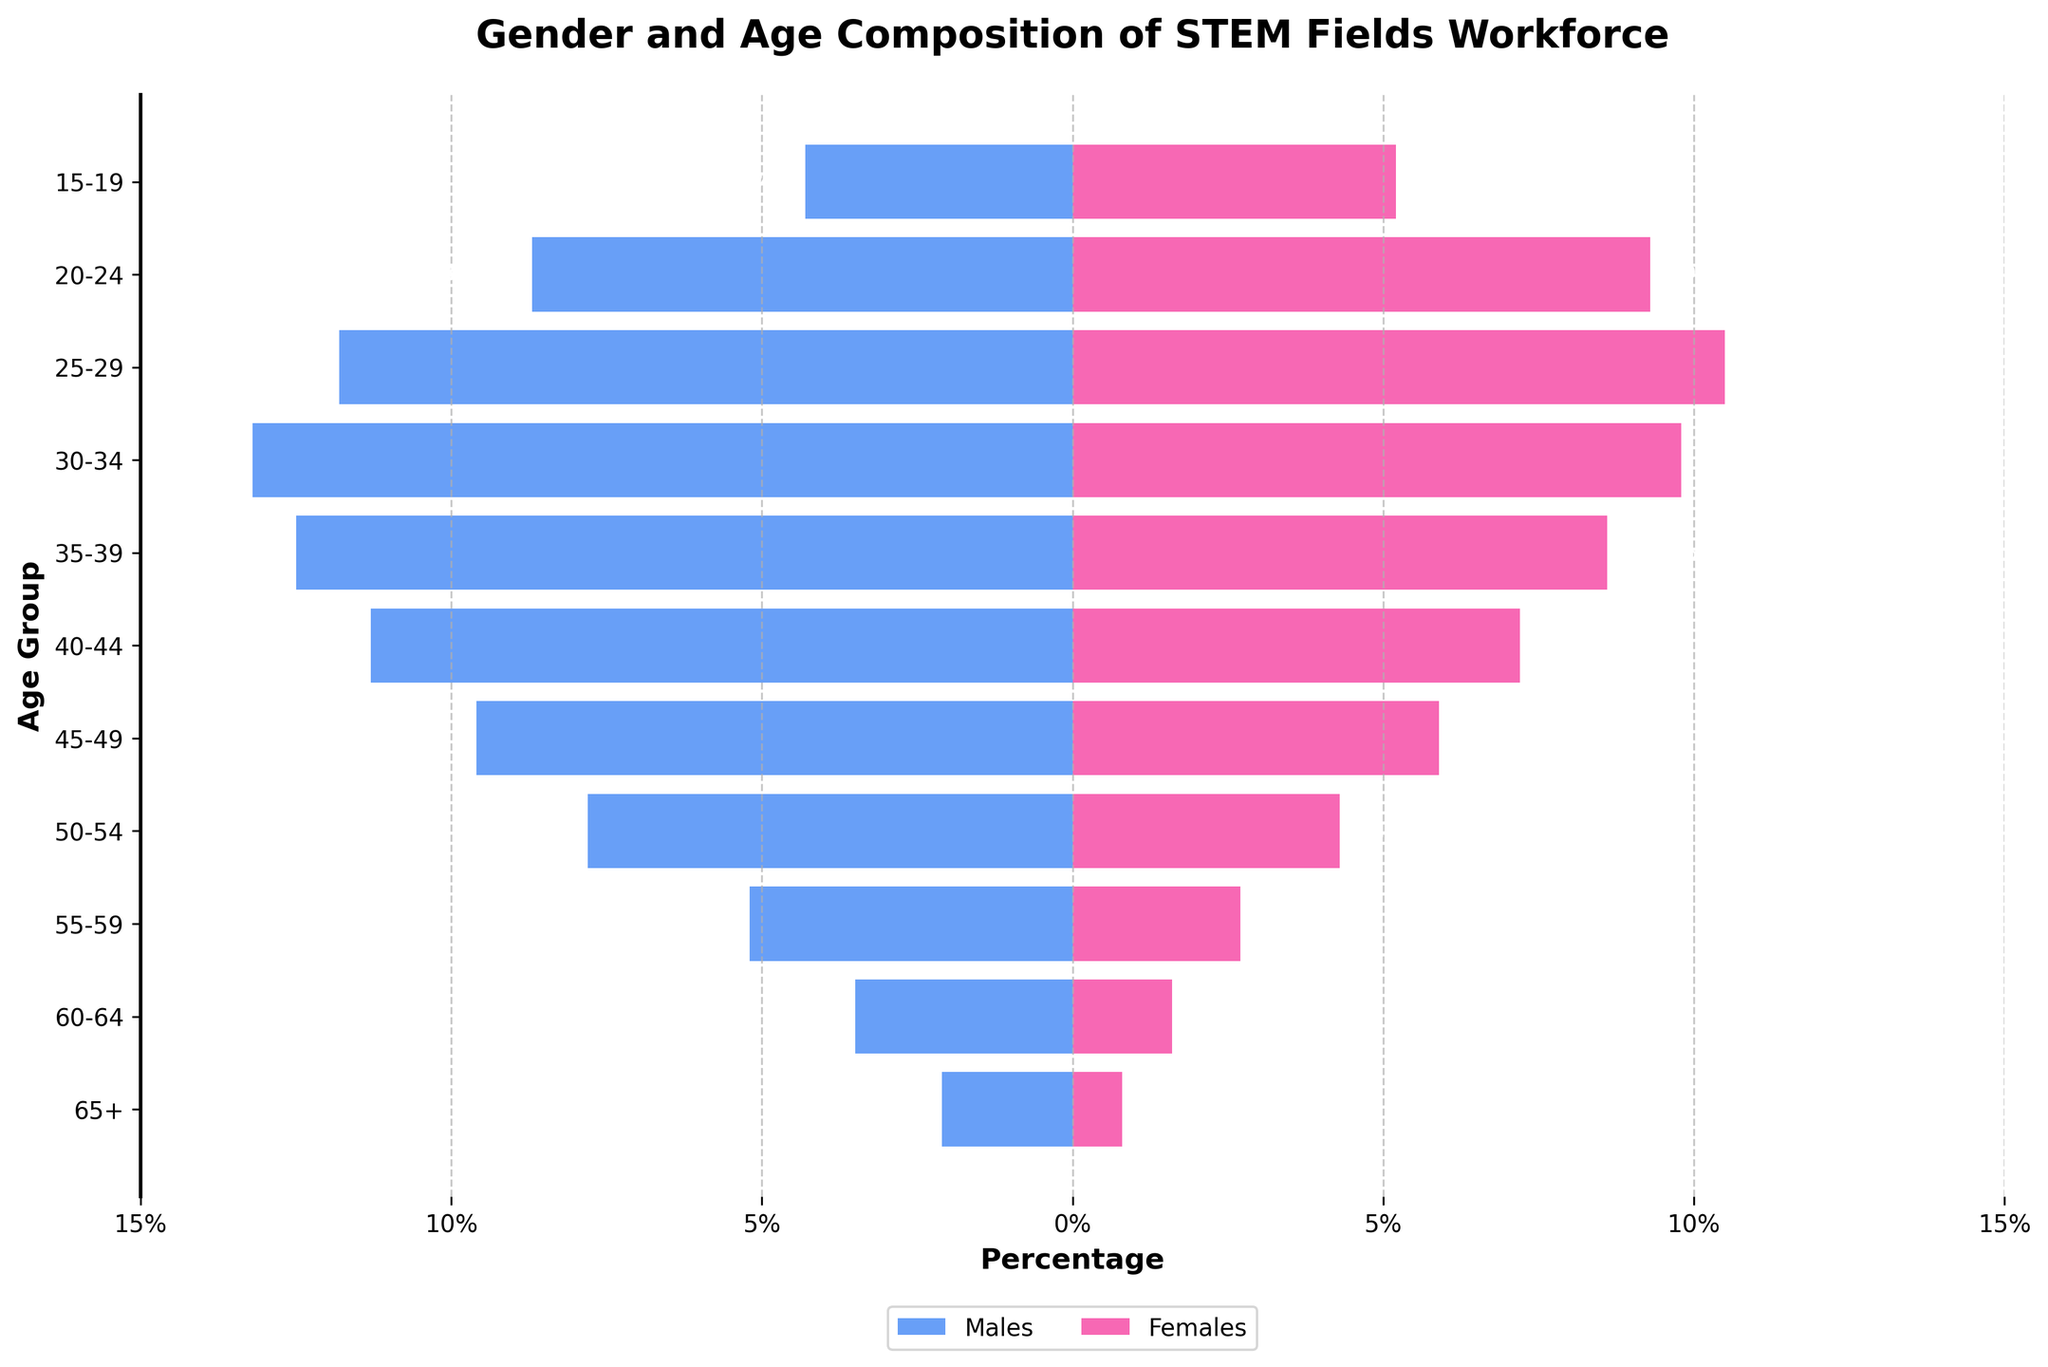What is the title of the figure? The title is displayed at the top of the plot. It indicates what the chart represents.
Answer: Gender and Age Composition of STEM Fields Workforce What percentage of males are in the 45-49 age group? The percentage of males in the 45-49 age group is shown on the left bar corresponding to the 45-49 label.
Answer: 9.6% How does the percentage of females in the 60-64 age group compare to that in the 50-54 age group? Look at the bars corresponding to the 60-64 and 50-54 age groups for females. Compare their lengths.
Answer: 60-64 group has 1.6%, and 50-54 group has 4.3%. The 60-64 percentage is less Which age group has the highest representation of females? Look for the longest bar on the female side of the plot.
Answer: 25-29 What is the combined percentage of males and females in the 25-29 age group? Add the percentage of males and females in the 25-29 age group.
Answer: 11.8% + 10.5% = 22.3% In which age group is the gender gap the largest? Find the age group with the biggest difference between male and female percentages.
Answer: 65+ How does the workforce composition change from the 30-34 age group to the 35-39 age group in terms of male percentage? Compare the male representation in the 30-34 and 35-39 age groups.
Answer: It increases from 13.2% to 12.5% What percentage of the workforce is under 20 years old? Add the male and female percentages for the 15-19 age group.
Answer: 4.3% + 5.2% = 9.5% Which gender has a consistently higher representation across the age groups? Compare the overall trend of male and female bars across the age groups.
Answer: Males How many age groups are represented in the chart? Count the distinct age groups listed on the y-axis.
Answer: 11 